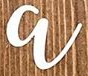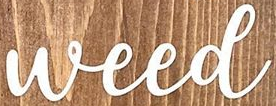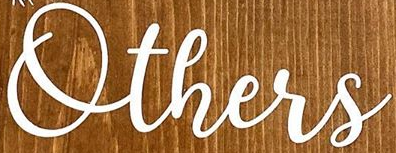Read the text content from these images in order, separated by a semicolon. a; Weed; Others 